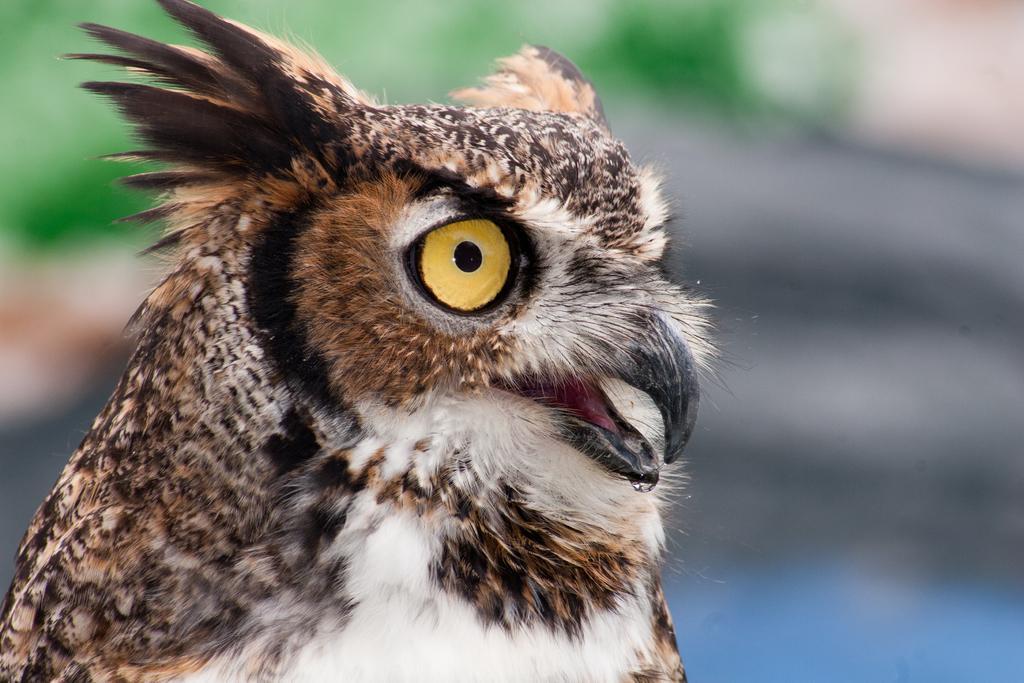Describe this image in one or two sentences. In this image we can see an owl. 